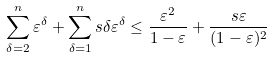<formula> <loc_0><loc_0><loc_500><loc_500>\sum _ { \delta = 2 } ^ { n } \varepsilon ^ { \delta } + \sum _ { \delta = 1 } ^ { n } s \delta \varepsilon ^ { \delta } & \leq \frac { \varepsilon ^ { 2 } } { 1 - \varepsilon } + \frac { s \varepsilon } { ( 1 - \varepsilon ) ^ { 2 } }</formula> 